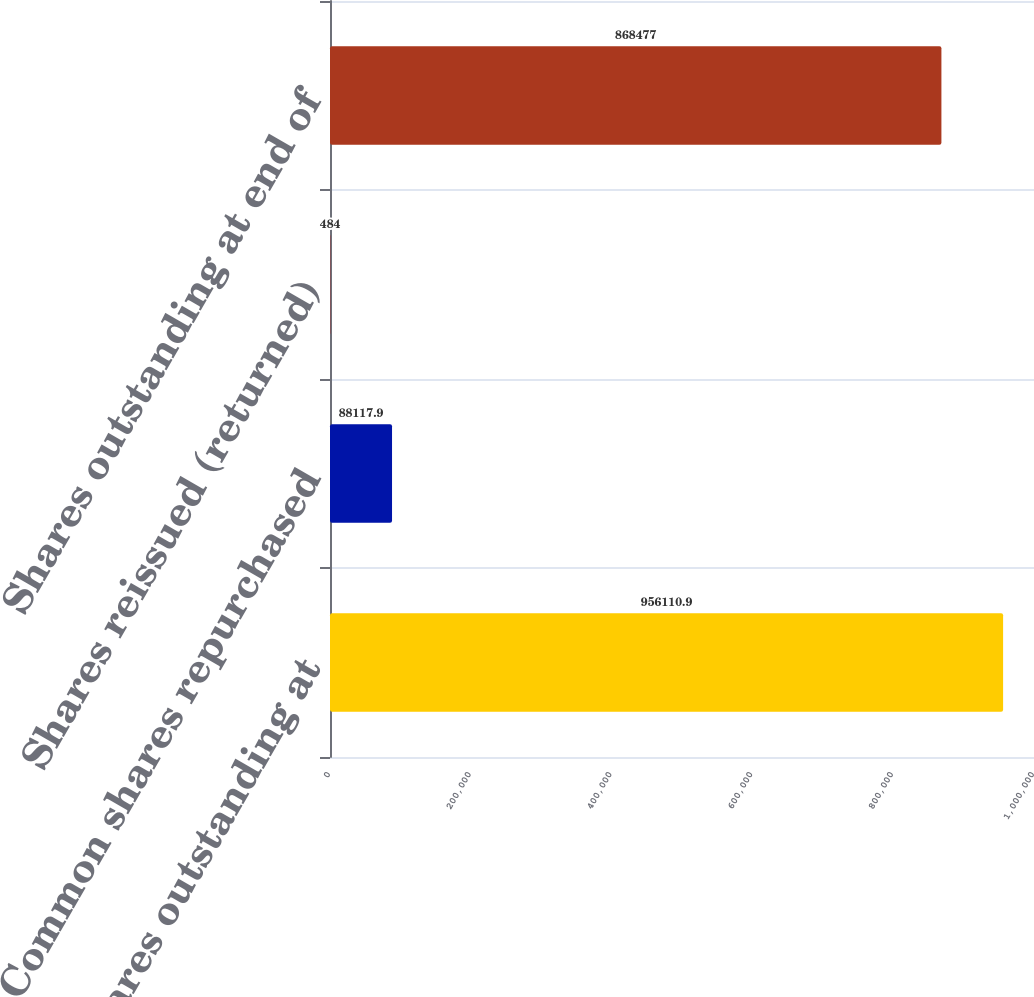<chart> <loc_0><loc_0><loc_500><loc_500><bar_chart><fcel>Shares outstanding at<fcel>Common shares repurchased<fcel>Shares reissued (returned)<fcel>Shares outstanding at end of<nl><fcel>956111<fcel>88117.9<fcel>484<fcel>868477<nl></chart> 